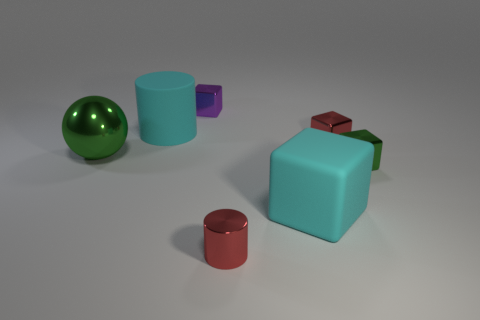Add 2 cyan objects. How many objects exist? 9 Subtract all cylinders. How many objects are left? 5 Subtract 0 blue spheres. How many objects are left? 7 Subtract all big cyan things. Subtract all small green objects. How many objects are left? 4 Add 4 tiny green metal objects. How many tiny green metal objects are left? 5 Add 2 tiny brown metal blocks. How many tiny brown metal blocks exist? 2 